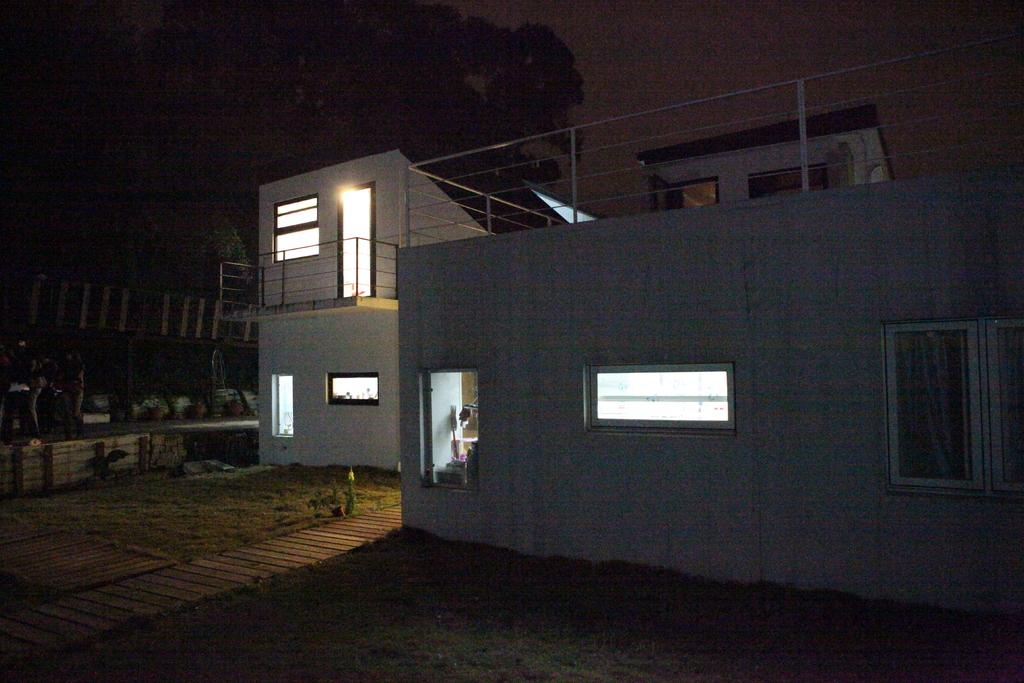What is the color of the building in the image? The building in the image is white-colored. What type of vegetation can be seen in the image? There is grass visible in the image. What type of light source is present in the image? There is a light in the image. How would you describe the lighting in the image? The image appears to be slightly dark in the background. What song is being sung by the people in the image? There are no people visible in the image, and therefore no singing can be observed. 